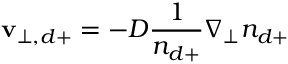<formula> <loc_0><loc_0><loc_500><loc_500>v _ { \perp , d + } = - D \frac { 1 } { n _ { d + } } \nabla _ { \perp } n _ { d + }</formula> 